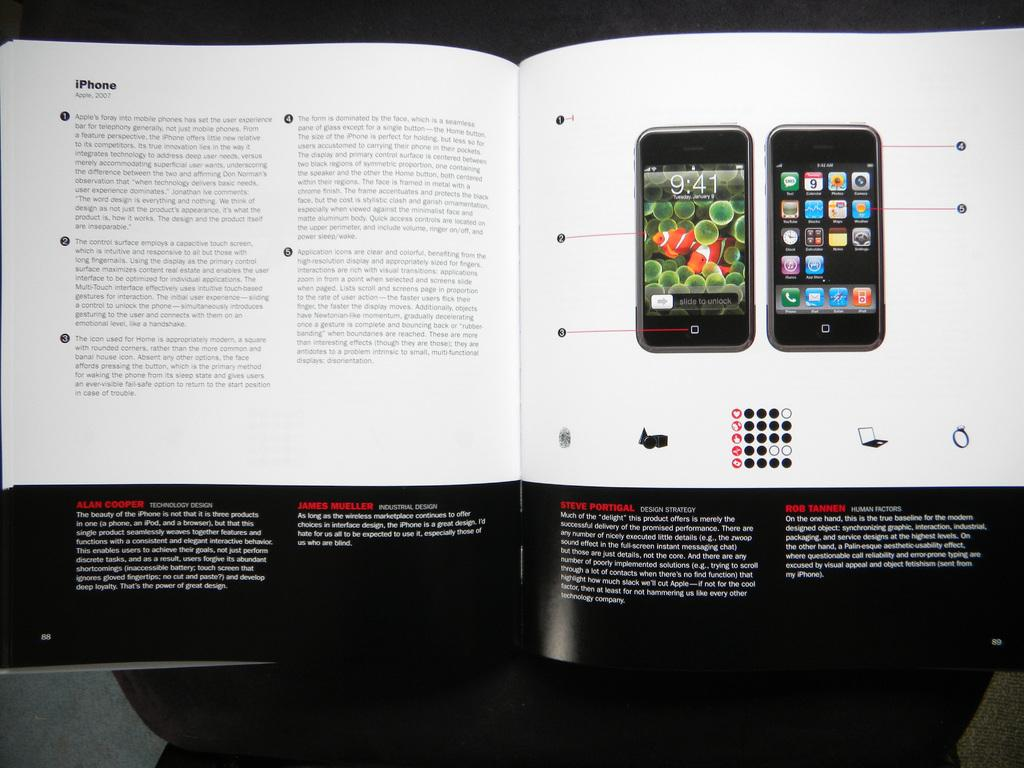What object is present in the image? There is a book in the image. What is depicted in the book? The book contains a picture of mobile phones. What type of content is in the book? There is printed text in the book. What type of furniture is shown in the image? There is no furniture present in the image; it only features a book. What is the position of the book in the image? The position of the book cannot be determined from the image alone, as it only shows the book and its contents. 